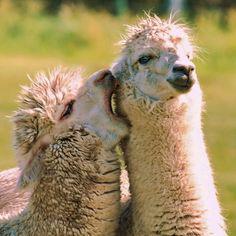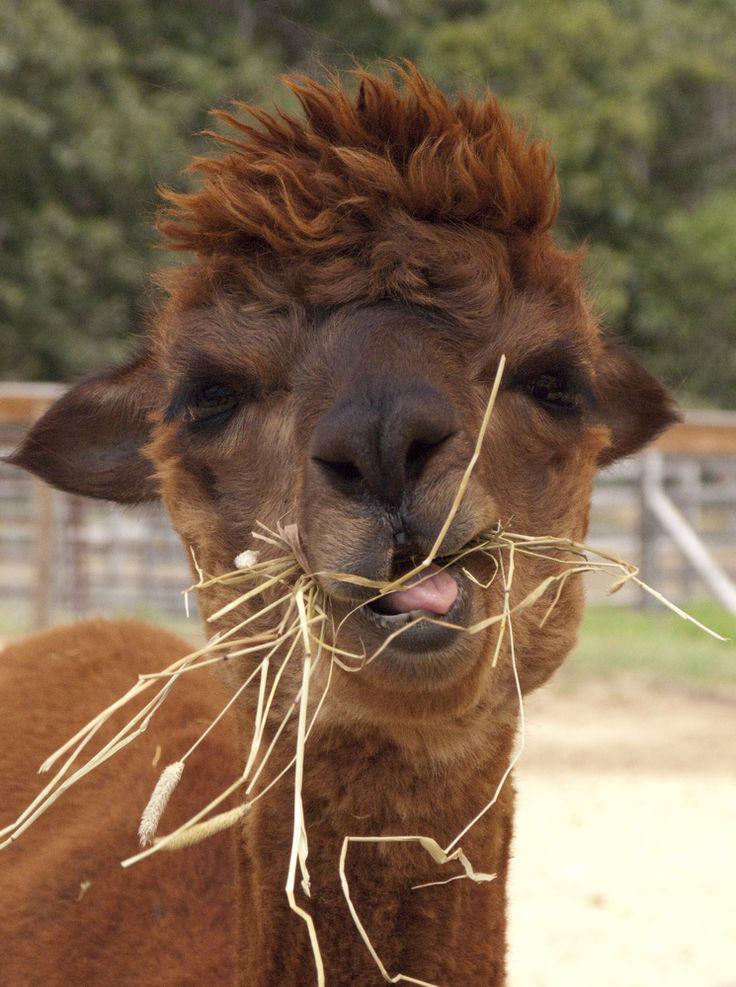The first image is the image on the left, the second image is the image on the right. Examine the images to the left and right. Is the description "In at least one image there is a single brown llama eating yellow hay." accurate? Answer yes or no. Yes. The first image is the image on the left, the second image is the image on the right. Considering the images on both sides, is "In one of the images, a llama has long strands of hay hanging out of its mouth." valid? Answer yes or no. Yes. 